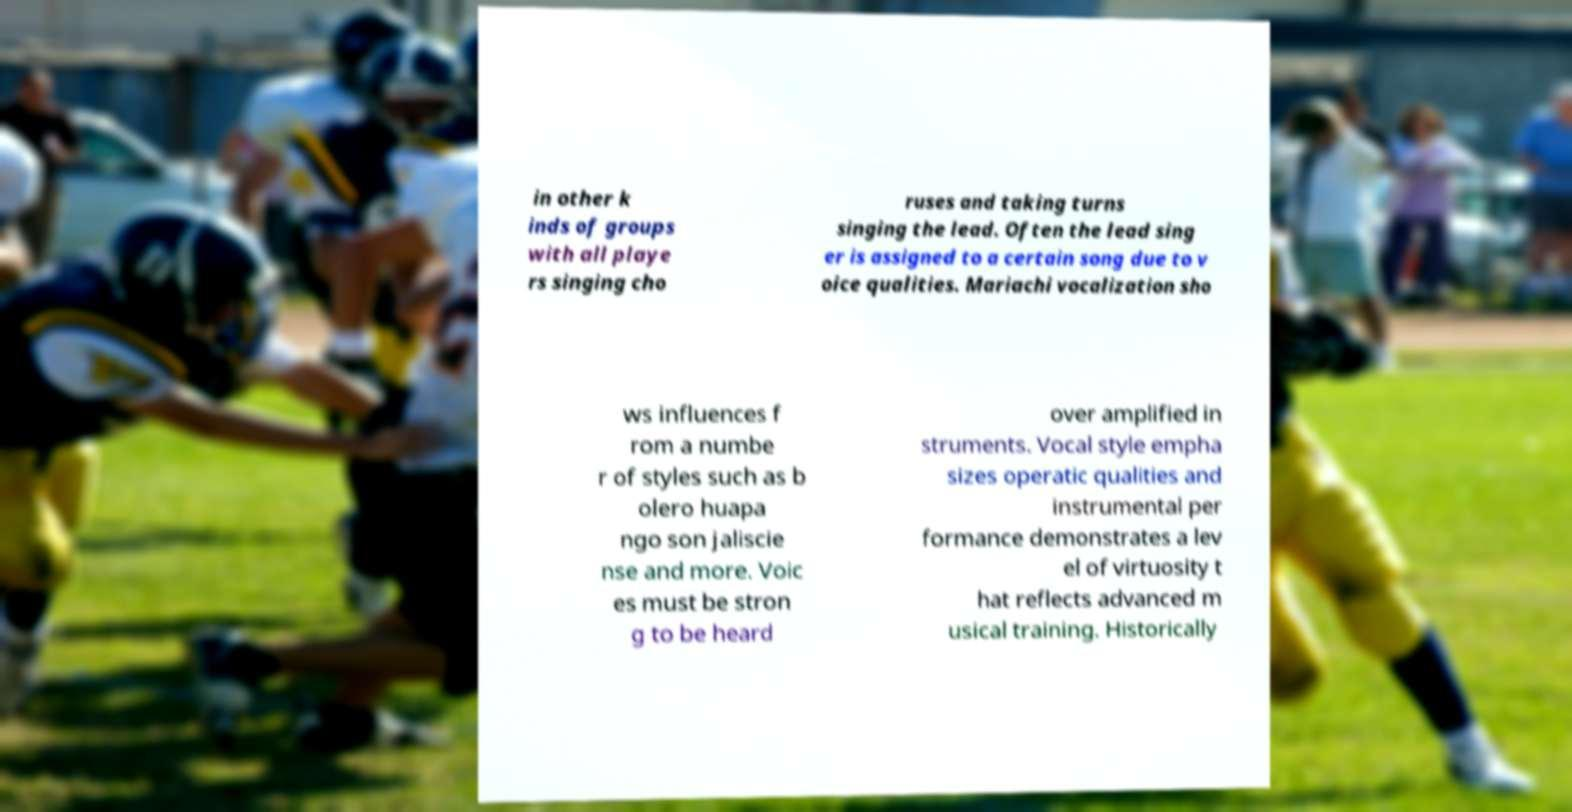For documentation purposes, I need the text within this image transcribed. Could you provide that? in other k inds of groups with all playe rs singing cho ruses and taking turns singing the lead. Often the lead sing er is assigned to a certain song due to v oice qualities. Mariachi vocalization sho ws influences f rom a numbe r of styles such as b olero huapa ngo son jaliscie nse and more. Voic es must be stron g to be heard over amplified in struments. Vocal style empha sizes operatic qualities and instrumental per formance demonstrates a lev el of virtuosity t hat reflects advanced m usical training. Historically 